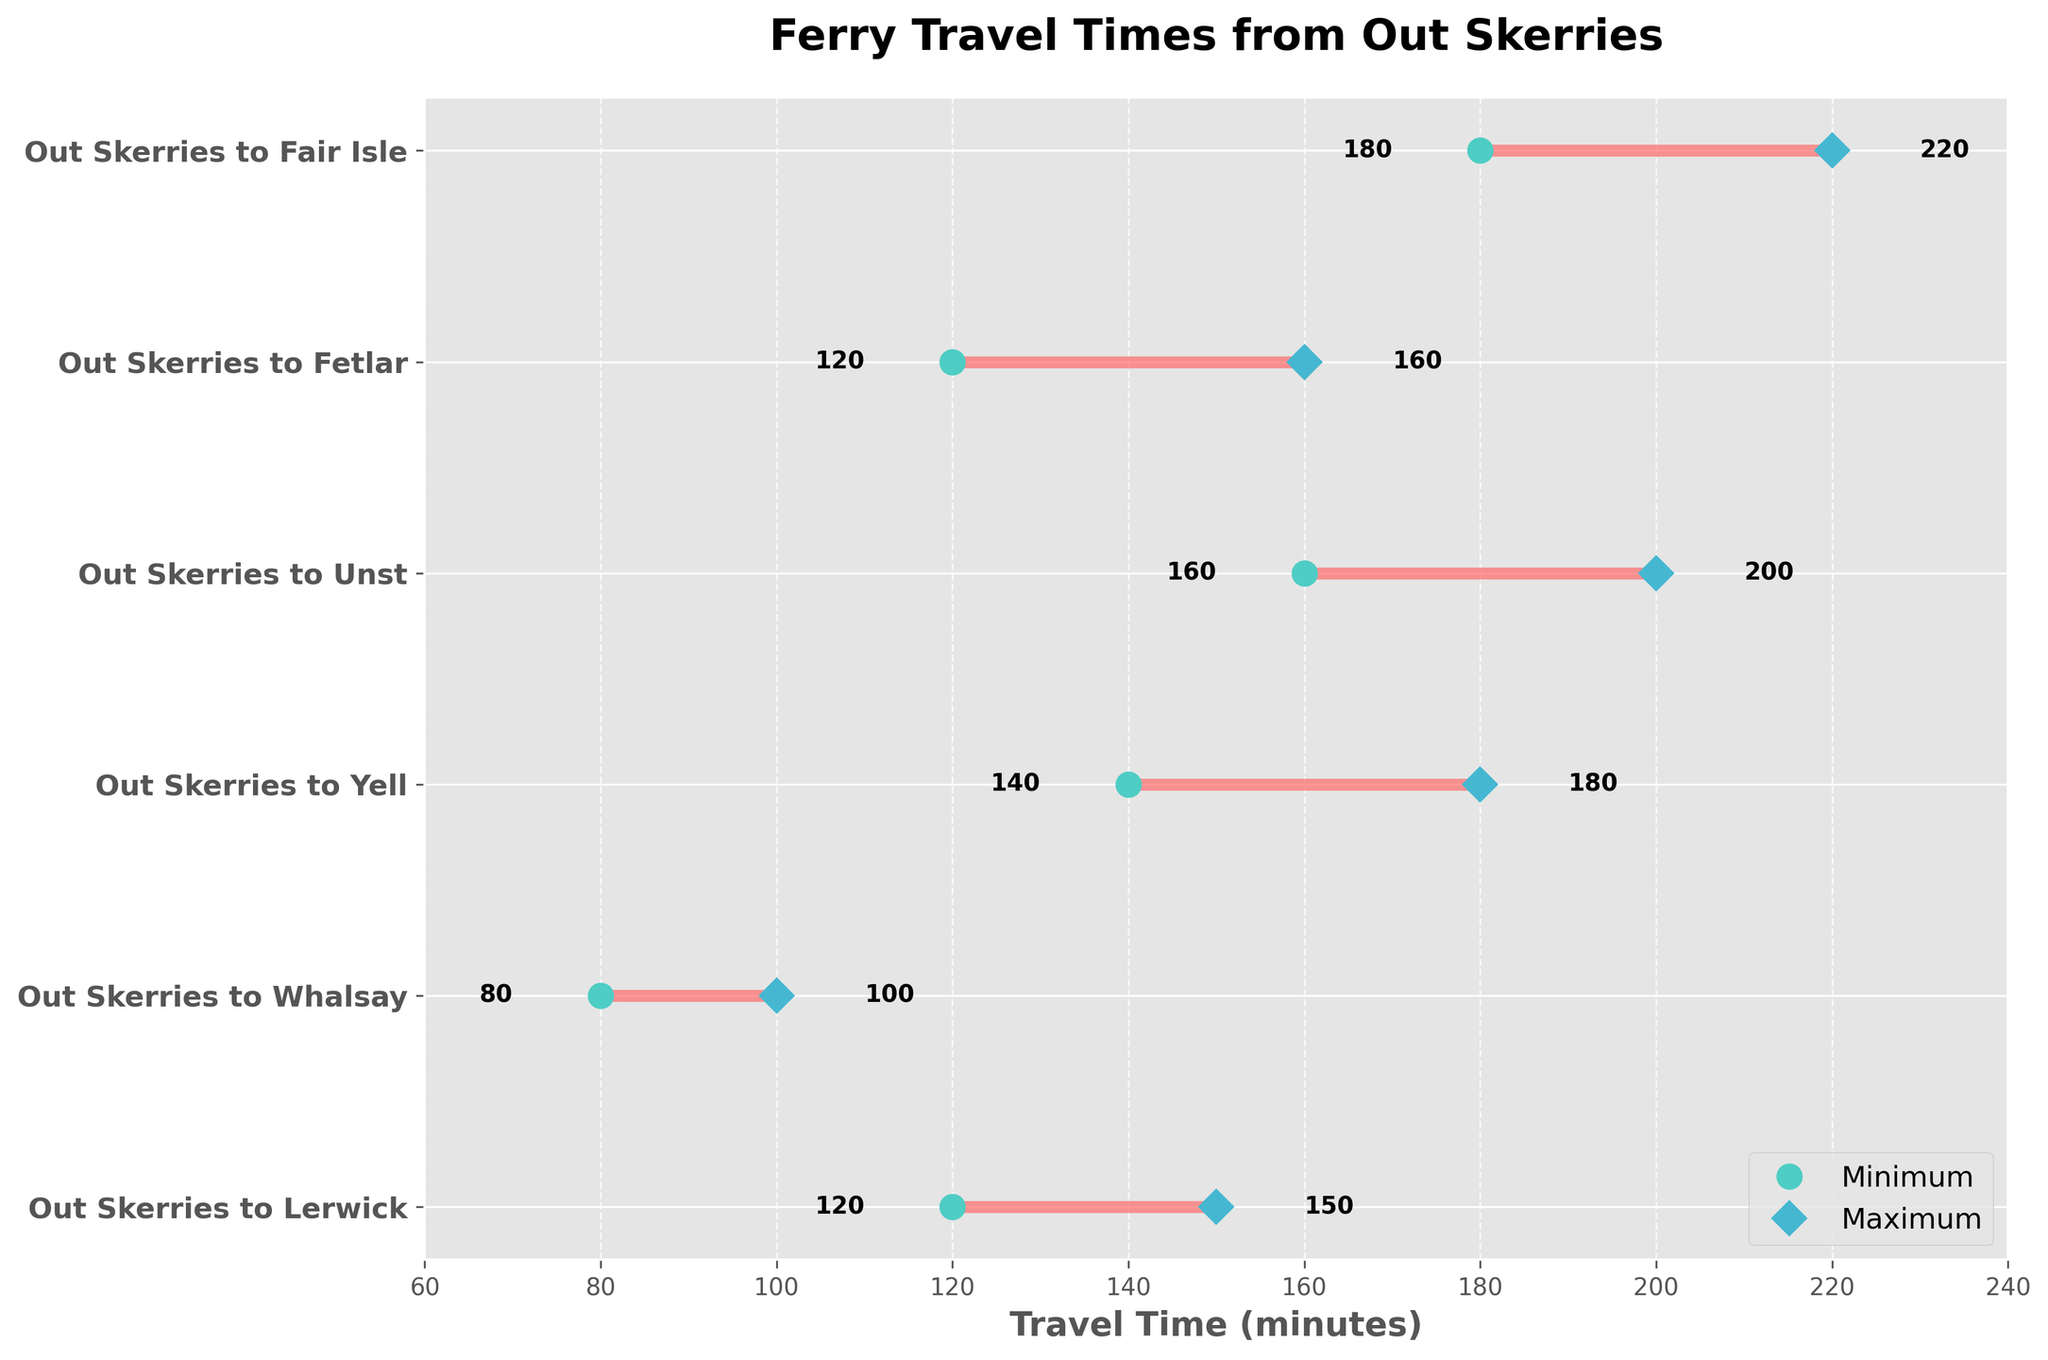What is the title of the figure? The title is located at the top of the figure in bold text. It reads: "Ferry Travel Times from Out Skerries."
Answer: Ferry Travel Times from Out Skerries How many ferry routes are displayed in the figure? Count the number of distinct horizontal lines or y-ticks representing the ferry routes. Each line corresponds to a different route.
Answer: Six What is the minimum travel time to Unst? Look for the marker labeled "Minimum" associated with the route "Out Skerries to Unst." The travel time is displayed near the starting point of the horizontal line for that route.
Answer: 160 minutes What range of travel times is represented for the route to Lerwick? Identify the endpoints of the horizontal line representing the route "Out Skerries to Lerwick." The minimum time is at one end and the maximum time is at the other.
Answer: 120 to 150 minutes Which route has the longest maximum travel time? Compare the maximum travel times for all routes by looking at the endpoints labeled "Maximum" for each horizontal line. Determine which one has the highest value.
Answer: Out Skerries to Fair Isle What is the difference between the minimum and maximum travel times to Yell? Identify the minimum and maximum travel times for the route "Out Skerries to Yell." Subtract the minimum time from the maximum time to find the difference.
Answer: 40 minutes For how many routes does the maximum travel time exceed 200 minutes? Check the "Maximum" markers for each route and count how many exceed the 200-minute mark. Look for markers labeled "Maximum" that are beyond 200 on the x-axis.
Answer: One What is the mean of the maximum travel times for all routes? Add up all the maximum travel times and divide by the number of routes. Calculate: (150 + 100 + 180 + 200 + 160 + 220) / 6.
Answer: 168.33 minutes Which route has the smallest range of travel times? Calculate the range for each route by subtracting the minimum time from the maximum time. Compare these ranges to determine the smallest one.
Answer: Out Skerries to Whalsay Is there any route with a minimum travel time less than 100 minutes? Check the "Minimum" markers for each route and determine if any of them have a value less than 100. Look for markers labeled "Minimum" below 100 on the x-axis.
Answer: Yes, Out Skerries to Whalsay 